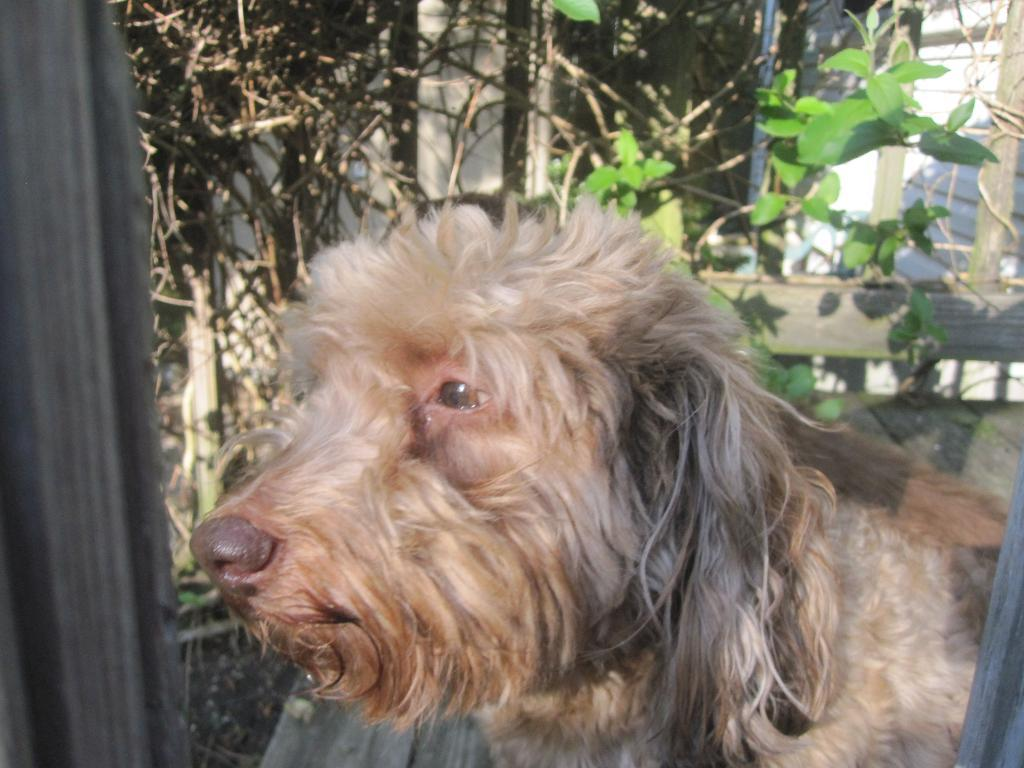What type of animal is in the image? There is a dog in the image. What is visible behind the dog? There are trees behind the dog. How are the trees arranged in the image? The trees resemble walls and a wooden fence. How many brothers can be seen playing with the dog in the image? There are no brothers present in the image; it only features a dog and trees. What type of flame is visible near the dog in the image? There is no flame present in the image; it only features a dog and trees. 